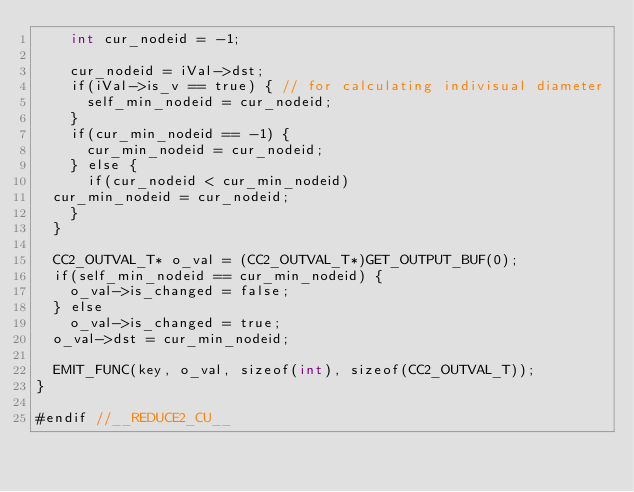Convert code to text. <code><loc_0><loc_0><loc_500><loc_500><_Cuda_>    int cur_nodeid = -1;

    cur_nodeid = iVal->dst;
    if(iVal->is_v == true) { // for calculating indivisual diameter
      self_min_nodeid = cur_nodeid;
    }
    if(cur_min_nodeid == -1) {
      cur_min_nodeid = cur_nodeid;
    } else {
      if(cur_nodeid < cur_min_nodeid)
	cur_min_nodeid = cur_nodeid;
    }
  }

  CC2_OUTVAL_T* o_val = (CC2_OUTVAL_T*)GET_OUTPUT_BUF(0);
  if(self_min_nodeid == cur_min_nodeid) {
    o_val->is_changed = false;
  } else 
    o_val->is_changed = true;
  o_val->dst = cur_min_nodeid;

  EMIT_FUNC(key, o_val, sizeof(int), sizeof(CC2_OUTVAL_T));
}

#endif //__REDUCE2_CU__
</code> 